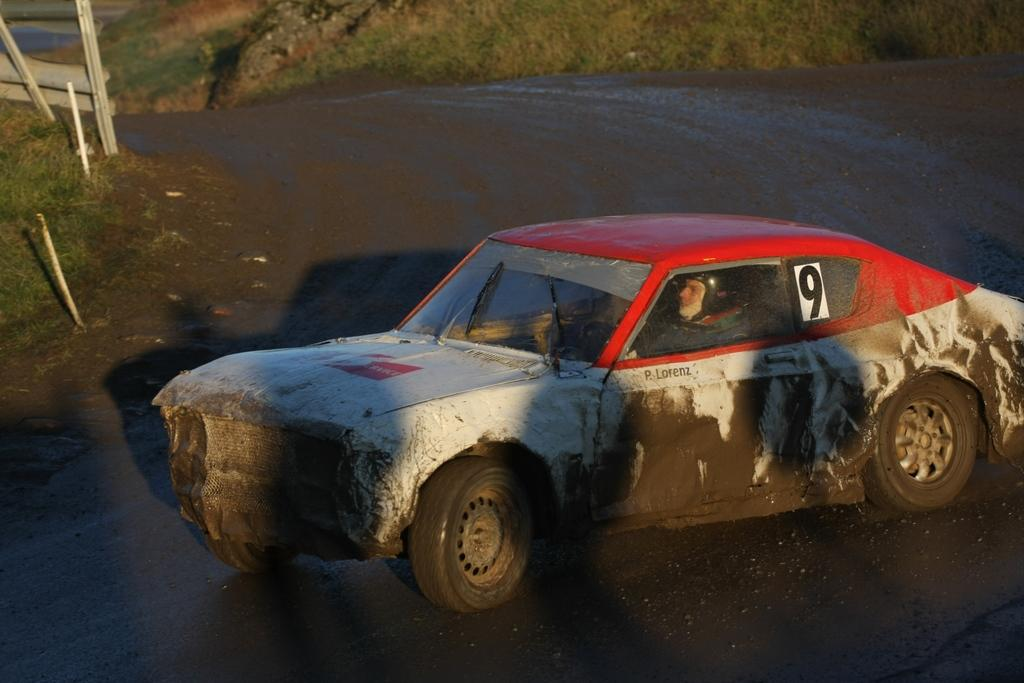What is the main subject of the image? There is a car on the road in the image. Who or what is inside the car? A person is sitting inside the car. What can be seen in the background of the image? There is grass visible on a hill in the background of the image. What word is being spoken by the person inside the car in the image? There is no indication in the image of what word, if any, is being spoken by the person inside the car. 